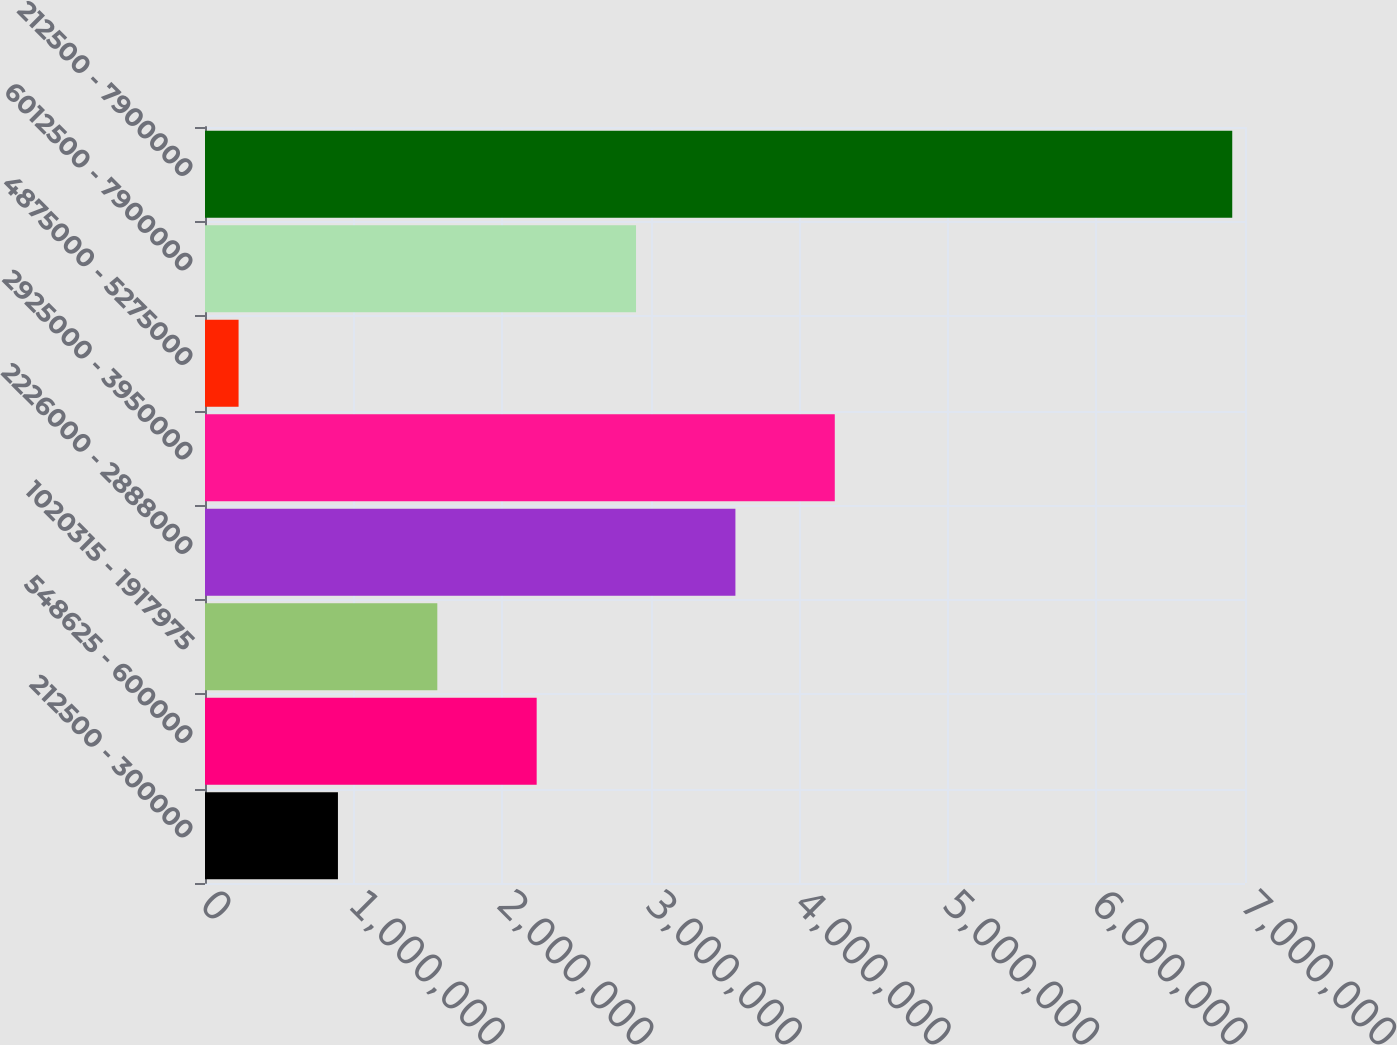<chart> <loc_0><loc_0><loc_500><loc_500><bar_chart><fcel>212500 - 300000<fcel>548625 - 600000<fcel>1020315 - 1917975<fcel>2226000 - 2888000<fcel>2925000 - 3950000<fcel>4875000 - 5275000<fcel>6012500 - 7900000<fcel>212500 - 7900000<nl><fcel>894813<fcel>2.23244e+06<fcel>1.56363e+06<fcel>3.57007e+06<fcel>4.23888e+06<fcel>226000<fcel>2.90125e+06<fcel>6.91413e+06<nl></chart> 